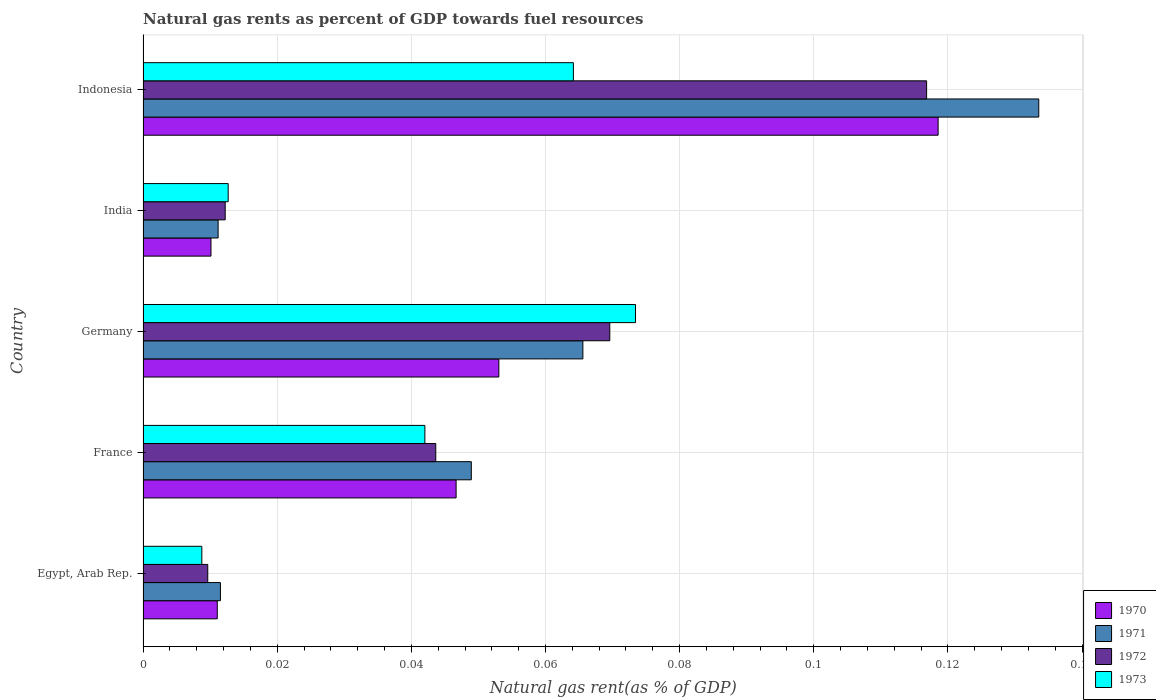How many groups of bars are there?
Your answer should be compact. 5. Are the number of bars per tick equal to the number of legend labels?
Make the answer very short. Yes. How many bars are there on the 4th tick from the top?
Ensure brevity in your answer.  4. How many bars are there on the 3rd tick from the bottom?
Make the answer very short. 4. What is the label of the 3rd group of bars from the top?
Make the answer very short. Germany. In how many cases, is the number of bars for a given country not equal to the number of legend labels?
Give a very brief answer. 0. What is the natural gas rent in 1972 in India?
Give a very brief answer. 0.01. Across all countries, what is the maximum natural gas rent in 1970?
Offer a terse response. 0.12. Across all countries, what is the minimum natural gas rent in 1973?
Ensure brevity in your answer.  0.01. In which country was the natural gas rent in 1972 minimum?
Ensure brevity in your answer.  Egypt, Arab Rep. What is the total natural gas rent in 1971 in the graph?
Give a very brief answer. 0.27. What is the difference between the natural gas rent in 1972 in France and that in India?
Keep it short and to the point. 0.03. What is the difference between the natural gas rent in 1972 in Egypt, Arab Rep. and the natural gas rent in 1971 in France?
Your answer should be compact. -0.04. What is the average natural gas rent in 1970 per country?
Provide a short and direct response. 0.05. What is the difference between the natural gas rent in 1972 and natural gas rent in 1971 in Germany?
Offer a very short reply. 0. In how many countries, is the natural gas rent in 1972 greater than 0.116 %?
Provide a succinct answer. 1. What is the ratio of the natural gas rent in 1970 in India to that in Indonesia?
Your answer should be compact. 0.09. Is the natural gas rent in 1971 in Egypt, Arab Rep. less than that in Indonesia?
Your answer should be compact. Yes. Is the difference between the natural gas rent in 1972 in Germany and Indonesia greater than the difference between the natural gas rent in 1971 in Germany and Indonesia?
Your response must be concise. Yes. What is the difference between the highest and the second highest natural gas rent in 1970?
Offer a very short reply. 0.07. What is the difference between the highest and the lowest natural gas rent in 1971?
Offer a very short reply. 0.12. In how many countries, is the natural gas rent in 1973 greater than the average natural gas rent in 1973 taken over all countries?
Offer a very short reply. 3. What does the 1st bar from the top in Indonesia represents?
Provide a short and direct response. 1973. Is it the case that in every country, the sum of the natural gas rent in 1972 and natural gas rent in 1970 is greater than the natural gas rent in 1971?
Provide a succinct answer. Yes. Are the values on the major ticks of X-axis written in scientific E-notation?
Your response must be concise. No. Does the graph contain grids?
Provide a succinct answer. Yes. Where does the legend appear in the graph?
Provide a succinct answer. Bottom right. What is the title of the graph?
Ensure brevity in your answer.  Natural gas rents as percent of GDP towards fuel resources. Does "1990" appear as one of the legend labels in the graph?
Give a very brief answer. No. What is the label or title of the X-axis?
Offer a very short reply. Natural gas rent(as % of GDP). What is the Natural gas rent(as % of GDP) of 1970 in Egypt, Arab Rep.?
Offer a very short reply. 0.01. What is the Natural gas rent(as % of GDP) in 1971 in Egypt, Arab Rep.?
Keep it short and to the point. 0.01. What is the Natural gas rent(as % of GDP) in 1972 in Egypt, Arab Rep.?
Keep it short and to the point. 0.01. What is the Natural gas rent(as % of GDP) of 1973 in Egypt, Arab Rep.?
Keep it short and to the point. 0.01. What is the Natural gas rent(as % of GDP) in 1970 in France?
Your response must be concise. 0.05. What is the Natural gas rent(as % of GDP) in 1971 in France?
Your answer should be very brief. 0.05. What is the Natural gas rent(as % of GDP) in 1972 in France?
Your answer should be very brief. 0.04. What is the Natural gas rent(as % of GDP) in 1973 in France?
Offer a terse response. 0.04. What is the Natural gas rent(as % of GDP) in 1970 in Germany?
Keep it short and to the point. 0.05. What is the Natural gas rent(as % of GDP) of 1971 in Germany?
Offer a very short reply. 0.07. What is the Natural gas rent(as % of GDP) in 1972 in Germany?
Your answer should be compact. 0.07. What is the Natural gas rent(as % of GDP) in 1973 in Germany?
Your answer should be very brief. 0.07. What is the Natural gas rent(as % of GDP) of 1970 in India?
Keep it short and to the point. 0.01. What is the Natural gas rent(as % of GDP) in 1971 in India?
Give a very brief answer. 0.01. What is the Natural gas rent(as % of GDP) in 1972 in India?
Your answer should be very brief. 0.01. What is the Natural gas rent(as % of GDP) in 1973 in India?
Your answer should be compact. 0.01. What is the Natural gas rent(as % of GDP) of 1970 in Indonesia?
Provide a succinct answer. 0.12. What is the Natural gas rent(as % of GDP) of 1971 in Indonesia?
Your answer should be very brief. 0.13. What is the Natural gas rent(as % of GDP) of 1972 in Indonesia?
Offer a terse response. 0.12. What is the Natural gas rent(as % of GDP) of 1973 in Indonesia?
Offer a very short reply. 0.06. Across all countries, what is the maximum Natural gas rent(as % of GDP) of 1970?
Provide a short and direct response. 0.12. Across all countries, what is the maximum Natural gas rent(as % of GDP) of 1971?
Keep it short and to the point. 0.13. Across all countries, what is the maximum Natural gas rent(as % of GDP) of 1972?
Give a very brief answer. 0.12. Across all countries, what is the maximum Natural gas rent(as % of GDP) in 1973?
Give a very brief answer. 0.07. Across all countries, what is the minimum Natural gas rent(as % of GDP) of 1970?
Provide a short and direct response. 0.01. Across all countries, what is the minimum Natural gas rent(as % of GDP) of 1971?
Ensure brevity in your answer.  0.01. Across all countries, what is the minimum Natural gas rent(as % of GDP) in 1972?
Your answer should be very brief. 0.01. Across all countries, what is the minimum Natural gas rent(as % of GDP) of 1973?
Make the answer very short. 0.01. What is the total Natural gas rent(as % of GDP) of 1970 in the graph?
Make the answer very short. 0.24. What is the total Natural gas rent(as % of GDP) in 1971 in the graph?
Your response must be concise. 0.27. What is the total Natural gas rent(as % of GDP) of 1972 in the graph?
Your answer should be compact. 0.25. What is the total Natural gas rent(as % of GDP) in 1973 in the graph?
Offer a terse response. 0.2. What is the difference between the Natural gas rent(as % of GDP) of 1970 in Egypt, Arab Rep. and that in France?
Your response must be concise. -0.04. What is the difference between the Natural gas rent(as % of GDP) in 1971 in Egypt, Arab Rep. and that in France?
Your answer should be very brief. -0.04. What is the difference between the Natural gas rent(as % of GDP) in 1972 in Egypt, Arab Rep. and that in France?
Provide a short and direct response. -0.03. What is the difference between the Natural gas rent(as % of GDP) in 1973 in Egypt, Arab Rep. and that in France?
Ensure brevity in your answer.  -0.03. What is the difference between the Natural gas rent(as % of GDP) of 1970 in Egypt, Arab Rep. and that in Germany?
Offer a very short reply. -0.04. What is the difference between the Natural gas rent(as % of GDP) in 1971 in Egypt, Arab Rep. and that in Germany?
Provide a succinct answer. -0.05. What is the difference between the Natural gas rent(as % of GDP) of 1972 in Egypt, Arab Rep. and that in Germany?
Offer a terse response. -0.06. What is the difference between the Natural gas rent(as % of GDP) of 1973 in Egypt, Arab Rep. and that in Germany?
Offer a terse response. -0.06. What is the difference between the Natural gas rent(as % of GDP) of 1970 in Egypt, Arab Rep. and that in India?
Provide a short and direct response. 0. What is the difference between the Natural gas rent(as % of GDP) of 1972 in Egypt, Arab Rep. and that in India?
Ensure brevity in your answer.  -0. What is the difference between the Natural gas rent(as % of GDP) of 1973 in Egypt, Arab Rep. and that in India?
Your answer should be very brief. -0. What is the difference between the Natural gas rent(as % of GDP) of 1970 in Egypt, Arab Rep. and that in Indonesia?
Keep it short and to the point. -0.11. What is the difference between the Natural gas rent(as % of GDP) of 1971 in Egypt, Arab Rep. and that in Indonesia?
Offer a very short reply. -0.12. What is the difference between the Natural gas rent(as % of GDP) of 1972 in Egypt, Arab Rep. and that in Indonesia?
Ensure brevity in your answer.  -0.11. What is the difference between the Natural gas rent(as % of GDP) of 1973 in Egypt, Arab Rep. and that in Indonesia?
Your response must be concise. -0.06. What is the difference between the Natural gas rent(as % of GDP) of 1970 in France and that in Germany?
Give a very brief answer. -0.01. What is the difference between the Natural gas rent(as % of GDP) in 1971 in France and that in Germany?
Your answer should be very brief. -0.02. What is the difference between the Natural gas rent(as % of GDP) in 1972 in France and that in Germany?
Make the answer very short. -0.03. What is the difference between the Natural gas rent(as % of GDP) of 1973 in France and that in Germany?
Keep it short and to the point. -0.03. What is the difference between the Natural gas rent(as % of GDP) of 1970 in France and that in India?
Offer a terse response. 0.04. What is the difference between the Natural gas rent(as % of GDP) of 1971 in France and that in India?
Provide a short and direct response. 0.04. What is the difference between the Natural gas rent(as % of GDP) of 1972 in France and that in India?
Your answer should be very brief. 0.03. What is the difference between the Natural gas rent(as % of GDP) in 1973 in France and that in India?
Keep it short and to the point. 0.03. What is the difference between the Natural gas rent(as % of GDP) of 1970 in France and that in Indonesia?
Your answer should be compact. -0.07. What is the difference between the Natural gas rent(as % of GDP) of 1971 in France and that in Indonesia?
Your answer should be compact. -0.08. What is the difference between the Natural gas rent(as % of GDP) of 1972 in France and that in Indonesia?
Your response must be concise. -0.07. What is the difference between the Natural gas rent(as % of GDP) of 1973 in France and that in Indonesia?
Keep it short and to the point. -0.02. What is the difference between the Natural gas rent(as % of GDP) in 1970 in Germany and that in India?
Give a very brief answer. 0.04. What is the difference between the Natural gas rent(as % of GDP) in 1971 in Germany and that in India?
Make the answer very short. 0.05. What is the difference between the Natural gas rent(as % of GDP) of 1972 in Germany and that in India?
Provide a short and direct response. 0.06. What is the difference between the Natural gas rent(as % of GDP) in 1973 in Germany and that in India?
Offer a terse response. 0.06. What is the difference between the Natural gas rent(as % of GDP) of 1970 in Germany and that in Indonesia?
Keep it short and to the point. -0.07. What is the difference between the Natural gas rent(as % of GDP) of 1971 in Germany and that in Indonesia?
Give a very brief answer. -0.07. What is the difference between the Natural gas rent(as % of GDP) in 1972 in Germany and that in Indonesia?
Give a very brief answer. -0.05. What is the difference between the Natural gas rent(as % of GDP) of 1973 in Germany and that in Indonesia?
Make the answer very short. 0.01. What is the difference between the Natural gas rent(as % of GDP) in 1970 in India and that in Indonesia?
Keep it short and to the point. -0.11. What is the difference between the Natural gas rent(as % of GDP) in 1971 in India and that in Indonesia?
Provide a short and direct response. -0.12. What is the difference between the Natural gas rent(as % of GDP) of 1972 in India and that in Indonesia?
Provide a short and direct response. -0.1. What is the difference between the Natural gas rent(as % of GDP) of 1973 in India and that in Indonesia?
Your answer should be compact. -0.05. What is the difference between the Natural gas rent(as % of GDP) of 1970 in Egypt, Arab Rep. and the Natural gas rent(as % of GDP) of 1971 in France?
Offer a terse response. -0.04. What is the difference between the Natural gas rent(as % of GDP) of 1970 in Egypt, Arab Rep. and the Natural gas rent(as % of GDP) of 1972 in France?
Your answer should be compact. -0.03. What is the difference between the Natural gas rent(as % of GDP) of 1970 in Egypt, Arab Rep. and the Natural gas rent(as % of GDP) of 1973 in France?
Give a very brief answer. -0.03. What is the difference between the Natural gas rent(as % of GDP) of 1971 in Egypt, Arab Rep. and the Natural gas rent(as % of GDP) of 1972 in France?
Your response must be concise. -0.03. What is the difference between the Natural gas rent(as % of GDP) in 1971 in Egypt, Arab Rep. and the Natural gas rent(as % of GDP) in 1973 in France?
Give a very brief answer. -0.03. What is the difference between the Natural gas rent(as % of GDP) in 1972 in Egypt, Arab Rep. and the Natural gas rent(as % of GDP) in 1973 in France?
Give a very brief answer. -0.03. What is the difference between the Natural gas rent(as % of GDP) in 1970 in Egypt, Arab Rep. and the Natural gas rent(as % of GDP) in 1971 in Germany?
Ensure brevity in your answer.  -0.05. What is the difference between the Natural gas rent(as % of GDP) in 1970 in Egypt, Arab Rep. and the Natural gas rent(as % of GDP) in 1972 in Germany?
Your answer should be compact. -0.06. What is the difference between the Natural gas rent(as % of GDP) of 1970 in Egypt, Arab Rep. and the Natural gas rent(as % of GDP) of 1973 in Germany?
Your response must be concise. -0.06. What is the difference between the Natural gas rent(as % of GDP) of 1971 in Egypt, Arab Rep. and the Natural gas rent(as % of GDP) of 1972 in Germany?
Ensure brevity in your answer.  -0.06. What is the difference between the Natural gas rent(as % of GDP) in 1971 in Egypt, Arab Rep. and the Natural gas rent(as % of GDP) in 1973 in Germany?
Make the answer very short. -0.06. What is the difference between the Natural gas rent(as % of GDP) of 1972 in Egypt, Arab Rep. and the Natural gas rent(as % of GDP) of 1973 in Germany?
Your answer should be compact. -0.06. What is the difference between the Natural gas rent(as % of GDP) of 1970 in Egypt, Arab Rep. and the Natural gas rent(as % of GDP) of 1971 in India?
Your answer should be compact. -0. What is the difference between the Natural gas rent(as % of GDP) of 1970 in Egypt, Arab Rep. and the Natural gas rent(as % of GDP) of 1972 in India?
Keep it short and to the point. -0. What is the difference between the Natural gas rent(as % of GDP) of 1970 in Egypt, Arab Rep. and the Natural gas rent(as % of GDP) of 1973 in India?
Offer a terse response. -0. What is the difference between the Natural gas rent(as % of GDP) of 1971 in Egypt, Arab Rep. and the Natural gas rent(as % of GDP) of 1972 in India?
Your response must be concise. -0. What is the difference between the Natural gas rent(as % of GDP) of 1971 in Egypt, Arab Rep. and the Natural gas rent(as % of GDP) of 1973 in India?
Make the answer very short. -0. What is the difference between the Natural gas rent(as % of GDP) in 1972 in Egypt, Arab Rep. and the Natural gas rent(as % of GDP) in 1973 in India?
Your answer should be very brief. -0. What is the difference between the Natural gas rent(as % of GDP) of 1970 in Egypt, Arab Rep. and the Natural gas rent(as % of GDP) of 1971 in Indonesia?
Provide a succinct answer. -0.12. What is the difference between the Natural gas rent(as % of GDP) in 1970 in Egypt, Arab Rep. and the Natural gas rent(as % of GDP) in 1972 in Indonesia?
Ensure brevity in your answer.  -0.11. What is the difference between the Natural gas rent(as % of GDP) of 1970 in Egypt, Arab Rep. and the Natural gas rent(as % of GDP) of 1973 in Indonesia?
Give a very brief answer. -0.05. What is the difference between the Natural gas rent(as % of GDP) of 1971 in Egypt, Arab Rep. and the Natural gas rent(as % of GDP) of 1972 in Indonesia?
Offer a terse response. -0.11. What is the difference between the Natural gas rent(as % of GDP) of 1971 in Egypt, Arab Rep. and the Natural gas rent(as % of GDP) of 1973 in Indonesia?
Your answer should be compact. -0.05. What is the difference between the Natural gas rent(as % of GDP) in 1972 in Egypt, Arab Rep. and the Natural gas rent(as % of GDP) in 1973 in Indonesia?
Give a very brief answer. -0.05. What is the difference between the Natural gas rent(as % of GDP) in 1970 in France and the Natural gas rent(as % of GDP) in 1971 in Germany?
Provide a short and direct response. -0.02. What is the difference between the Natural gas rent(as % of GDP) of 1970 in France and the Natural gas rent(as % of GDP) of 1972 in Germany?
Keep it short and to the point. -0.02. What is the difference between the Natural gas rent(as % of GDP) in 1970 in France and the Natural gas rent(as % of GDP) in 1973 in Germany?
Provide a succinct answer. -0.03. What is the difference between the Natural gas rent(as % of GDP) of 1971 in France and the Natural gas rent(as % of GDP) of 1972 in Germany?
Provide a short and direct response. -0.02. What is the difference between the Natural gas rent(as % of GDP) in 1971 in France and the Natural gas rent(as % of GDP) in 1973 in Germany?
Ensure brevity in your answer.  -0.02. What is the difference between the Natural gas rent(as % of GDP) in 1972 in France and the Natural gas rent(as % of GDP) in 1973 in Germany?
Your response must be concise. -0.03. What is the difference between the Natural gas rent(as % of GDP) of 1970 in France and the Natural gas rent(as % of GDP) of 1971 in India?
Offer a terse response. 0.04. What is the difference between the Natural gas rent(as % of GDP) in 1970 in France and the Natural gas rent(as % of GDP) in 1972 in India?
Provide a short and direct response. 0.03. What is the difference between the Natural gas rent(as % of GDP) in 1970 in France and the Natural gas rent(as % of GDP) in 1973 in India?
Keep it short and to the point. 0.03. What is the difference between the Natural gas rent(as % of GDP) in 1971 in France and the Natural gas rent(as % of GDP) in 1972 in India?
Make the answer very short. 0.04. What is the difference between the Natural gas rent(as % of GDP) of 1971 in France and the Natural gas rent(as % of GDP) of 1973 in India?
Your answer should be very brief. 0.04. What is the difference between the Natural gas rent(as % of GDP) in 1972 in France and the Natural gas rent(as % of GDP) in 1973 in India?
Ensure brevity in your answer.  0.03. What is the difference between the Natural gas rent(as % of GDP) of 1970 in France and the Natural gas rent(as % of GDP) of 1971 in Indonesia?
Your answer should be very brief. -0.09. What is the difference between the Natural gas rent(as % of GDP) in 1970 in France and the Natural gas rent(as % of GDP) in 1972 in Indonesia?
Your answer should be compact. -0.07. What is the difference between the Natural gas rent(as % of GDP) in 1970 in France and the Natural gas rent(as % of GDP) in 1973 in Indonesia?
Offer a very short reply. -0.02. What is the difference between the Natural gas rent(as % of GDP) in 1971 in France and the Natural gas rent(as % of GDP) in 1972 in Indonesia?
Make the answer very short. -0.07. What is the difference between the Natural gas rent(as % of GDP) of 1971 in France and the Natural gas rent(as % of GDP) of 1973 in Indonesia?
Your answer should be very brief. -0.02. What is the difference between the Natural gas rent(as % of GDP) in 1972 in France and the Natural gas rent(as % of GDP) in 1973 in Indonesia?
Give a very brief answer. -0.02. What is the difference between the Natural gas rent(as % of GDP) of 1970 in Germany and the Natural gas rent(as % of GDP) of 1971 in India?
Offer a terse response. 0.04. What is the difference between the Natural gas rent(as % of GDP) in 1970 in Germany and the Natural gas rent(as % of GDP) in 1972 in India?
Provide a succinct answer. 0.04. What is the difference between the Natural gas rent(as % of GDP) in 1970 in Germany and the Natural gas rent(as % of GDP) in 1973 in India?
Make the answer very short. 0.04. What is the difference between the Natural gas rent(as % of GDP) of 1971 in Germany and the Natural gas rent(as % of GDP) of 1972 in India?
Your answer should be compact. 0.05. What is the difference between the Natural gas rent(as % of GDP) in 1971 in Germany and the Natural gas rent(as % of GDP) in 1973 in India?
Provide a short and direct response. 0.05. What is the difference between the Natural gas rent(as % of GDP) of 1972 in Germany and the Natural gas rent(as % of GDP) of 1973 in India?
Keep it short and to the point. 0.06. What is the difference between the Natural gas rent(as % of GDP) in 1970 in Germany and the Natural gas rent(as % of GDP) in 1971 in Indonesia?
Make the answer very short. -0.08. What is the difference between the Natural gas rent(as % of GDP) of 1970 in Germany and the Natural gas rent(as % of GDP) of 1972 in Indonesia?
Your answer should be compact. -0.06. What is the difference between the Natural gas rent(as % of GDP) in 1970 in Germany and the Natural gas rent(as % of GDP) in 1973 in Indonesia?
Offer a terse response. -0.01. What is the difference between the Natural gas rent(as % of GDP) in 1971 in Germany and the Natural gas rent(as % of GDP) in 1972 in Indonesia?
Make the answer very short. -0.05. What is the difference between the Natural gas rent(as % of GDP) of 1971 in Germany and the Natural gas rent(as % of GDP) of 1973 in Indonesia?
Your answer should be compact. 0. What is the difference between the Natural gas rent(as % of GDP) in 1972 in Germany and the Natural gas rent(as % of GDP) in 1973 in Indonesia?
Your answer should be very brief. 0.01. What is the difference between the Natural gas rent(as % of GDP) in 1970 in India and the Natural gas rent(as % of GDP) in 1971 in Indonesia?
Provide a succinct answer. -0.12. What is the difference between the Natural gas rent(as % of GDP) in 1970 in India and the Natural gas rent(as % of GDP) in 1972 in Indonesia?
Your answer should be very brief. -0.11. What is the difference between the Natural gas rent(as % of GDP) of 1970 in India and the Natural gas rent(as % of GDP) of 1973 in Indonesia?
Keep it short and to the point. -0.05. What is the difference between the Natural gas rent(as % of GDP) in 1971 in India and the Natural gas rent(as % of GDP) in 1972 in Indonesia?
Provide a short and direct response. -0.11. What is the difference between the Natural gas rent(as % of GDP) of 1971 in India and the Natural gas rent(as % of GDP) of 1973 in Indonesia?
Provide a short and direct response. -0.05. What is the difference between the Natural gas rent(as % of GDP) of 1972 in India and the Natural gas rent(as % of GDP) of 1973 in Indonesia?
Keep it short and to the point. -0.05. What is the average Natural gas rent(as % of GDP) of 1970 per country?
Your answer should be compact. 0.05. What is the average Natural gas rent(as % of GDP) in 1971 per country?
Keep it short and to the point. 0.05. What is the average Natural gas rent(as % of GDP) in 1972 per country?
Make the answer very short. 0.05. What is the average Natural gas rent(as % of GDP) in 1973 per country?
Your answer should be compact. 0.04. What is the difference between the Natural gas rent(as % of GDP) in 1970 and Natural gas rent(as % of GDP) in 1971 in Egypt, Arab Rep.?
Provide a succinct answer. -0. What is the difference between the Natural gas rent(as % of GDP) in 1970 and Natural gas rent(as % of GDP) in 1972 in Egypt, Arab Rep.?
Offer a terse response. 0. What is the difference between the Natural gas rent(as % of GDP) of 1970 and Natural gas rent(as % of GDP) of 1973 in Egypt, Arab Rep.?
Make the answer very short. 0. What is the difference between the Natural gas rent(as % of GDP) in 1971 and Natural gas rent(as % of GDP) in 1972 in Egypt, Arab Rep.?
Provide a short and direct response. 0. What is the difference between the Natural gas rent(as % of GDP) in 1971 and Natural gas rent(as % of GDP) in 1973 in Egypt, Arab Rep.?
Offer a terse response. 0. What is the difference between the Natural gas rent(as % of GDP) of 1972 and Natural gas rent(as % of GDP) of 1973 in Egypt, Arab Rep.?
Make the answer very short. 0. What is the difference between the Natural gas rent(as % of GDP) of 1970 and Natural gas rent(as % of GDP) of 1971 in France?
Provide a short and direct response. -0. What is the difference between the Natural gas rent(as % of GDP) in 1970 and Natural gas rent(as % of GDP) in 1972 in France?
Keep it short and to the point. 0. What is the difference between the Natural gas rent(as % of GDP) in 1970 and Natural gas rent(as % of GDP) in 1973 in France?
Offer a very short reply. 0. What is the difference between the Natural gas rent(as % of GDP) in 1971 and Natural gas rent(as % of GDP) in 1972 in France?
Your answer should be compact. 0.01. What is the difference between the Natural gas rent(as % of GDP) of 1971 and Natural gas rent(as % of GDP) of 1973 in France?
Your response must be concise. 0.01. What is the difference between the Natural gas rent(as % of GDP) in 1972 and Natural gas rent(as % of GDP) in 1973 in France?
Keep it short and to the point. 0. What is the difference between the Natural gas rent(as % of GDP) in 1970 and Natural gas rent(as % of GDP) in 1971 in Germany?
Make the answer very short. -0.01. What is the difference between the Natural gas rent(as % of GDP) of 1970 and Natural gas rent(as % of GDP) of 1972 in Germany?
Make the answer very short. -0.02. What is the difference between the Natural gas rent(as % of GDP) in 1970 and Natural gas rent(as % of GDP) in 1973 in Germany?
Make the answer very short. -0.02. What is the difference between the Natural gas rent(as % of GDP) in 1971 and Natural gas rent(as % of GDP) in 1972 in Germany?
Give a very brief answer. -0. What is the difference between the Natural gas rent(as % of GDP) in 1971 and Natural gas rent(as % of GDP) in 1973 in Germany?
Ensure brevity in your answer.  -0.01. What is the difference between the Natural gas rent(as % of GDP) of 1972 and Natural gas rent(as % of GDP) of 1973 in Germany?
Ensure brevity in your answer.  -0. What is the difference between the Natural gas rent(as % of GDP) of 1970 and Natural gas rent(as % of GDP) of 1971 in India?
Offer a terse response. -0. What is the difference between the Natural gas rent(as % of GDP) in 1970 and Natural gas rent(as % of GDP) in 1972 in India?
Make the answer very short. -0. What is the difference between the Natural gas rent(as % of GDP) in 1970 and Natural gas rent(as % of GDP) in 1973 in India?
Offer a very short reply. -0. What is the difference between the Natural gas rent(as % of GDP) in 1971 and Natural gas rent(as % of GDP) in 1972 in India?
Your answer should be compact. -0. What is the difference between the Natural gas rent(as % of GDP) in 1971 and Natural gas rent(as % of GDP) in 1973 in India?
Your answer should be very brief. -0. What is the difference between the Natural gas rent(as % of GDP) in 1972 and Natural gas rent(as % of GDP) in 1973 in India?
Your response must be concise. -0. What is the difference between the Natural gas rent(as % of GDP) in 1970 and Natural gas rent(as % of GDP) in 1971 in Indonesia?
Ensure brevity in your answer.  -0.01. What is the difference between the Natural gas rent(as % of GDP) of 1970 and Natural gas rent(as % of GDP) of 1972 in Indonesia?
Provide a succinct answer. 0. What is the difference between the Natural gas rent(as % of GDP) of 1970 and Natural gas rent(as % of GDP) of 1973 in Indonesia?
Offer a very short reply. 0.05. What is the difference between the Natural gas rent(as % of GDP) in 1971 and Natural gas rent(as % of GDP) in 1972 in Indonesia?
Your response must be concise. 0.02. What is the difference between the Natural gas rent(as % of GDP) in 1971 and Natural gas rent(as % of GDP) in 1973 in Indonesia?
Keep it short and to the point. 0.07. What is the difference between the Natural gas rent(as % of GDP) in 1972 and Natural gas rent(as % of GDP) in 1973 in Indonesia?
Your response must be concise. 0.05. What is the ratio of the Natural gas rent(as % of GDP) in 1970 in Egypt, Arab Rep. to that in France?
Your answer should be very brief. 0.24. What is the ratio of the Natural gas rent(as % of GDP) in 1971 in Egypt, Arab Rep. to that in France?
Make the answer very short. 0.24. What is the ratio of the Natural gas rent(as % of GDP) in 1972 in Egypt, Arab Rep. to that in France?
Your answer should be very brief. 0.22. What is the ratio of the Natural gas rent(as % of GDP) in 1973 in Egypt, Arab Rep. to that in France?
Give a very brief answer. 0.21. What is the ratio of the Natural gas rent(as % of GDP) of 1970 in Egypt, Arab Rep. to that in Germany?
Offer a terse response. 0.21. What is the ratio of the Natural gas rent(as % of GDP) of 1971 in Egypt, Arab Rep. to that in Germany?
Your answer should be very brief. 0.18. What is the ratio of the Natural gas rent(as % of GDP) in 1972 in Egypt, Arab Rep. to that in Germany?
Give a very brief answer. 0.14. What is the ratio of the Natural gas rent(as % of GDP) in 1973 in Egypt, Arab Rep. to that in Germany?
Your response must be concise. 0.12. What is the ratio of the Natural gas rent(as % of GDP) in 1970 in Egypt, Arab Rep. to that in India?
Ensure brevity in your answer.  1.09. What is the ratio of the Natural gas rent(as % of GDP) in 1971 in Egypt, Arab Rep. to that in India?
Offer a terse response. 1.03. What is the ratio of the Natural gas rent(as % of GDP) of 1972 in Egypt, Arab Rep. to that in India?
Keep it short and to the point. 0.79. What is the ratio of the Natural gas rent(as % of GDP) of 1973 in Egypt, Arab Rep. to that in India?
Keep it short and to the point. 0.69. What is the ratio of the Natural gas rent(as % of GDP) in 1970 in Egypt, Arab Rep. to that in Indonesia?
Your response must be concise. 0.09. What is the ratio of the Natural gas rent(as % of GDP) of 1971 in Egypt, Arab Rep. to that in Indonesia?
Provide a short and direct response. 0.09. What is the ratio of the Natural gas rent(as % of GDP) of 1972 in Egypt, Arab Rep. to that in Indonesia?
Provide a short and direct response. 0.08. What is the ratio of the Natural gas rent(as % of GDP) of 1973 in Egypt, Arab Rep. to that in Indonesia?
Give a very brief answer. 0.14. What is the ratio of the Natural gas rent(as % of GDP) in 1970 in France to that in Germany?
Make the answer very short. 0.88. What is the ratio of the Natural gas rent(as % of GDP) in 1971 in France to that in Germany?
Your response must be concise. 0.75. What is the ratio of the Natural gas rent(as % of GDP) in 1972 in France to that in Germany?
Provide a succinct answer. 0.63. What is the ratio of the Natural gas rent(as % of GDP) in 1973 in France to that in Germany?
Offer a very short reply. 0.57. What is the ratio of the Natural gas rent(as % of GDP) of 1970 in France to that in India?
Ensure brevity in your answer.  4.61. What is the ratio of the Natural gas rent(as % of GDP) of 1971 in France to that in India?
Keep it short and to the point. 4.37. What is the ratio of the Natural gas rent(as % of GDP) of 1972 in France to that in India?
Your answer should be compact. 3.56. What is the ratio of the Natural gas rent(as % of GDP) in 1973 in France to that in India?
Make the answer very short. 3.31. What is the ratio of the Natural gas rent(as % of GDP) in 1970 in France to that in Indonesia?
Keep it short and to the point. 0.39. What is the ratio of the Natural gas rent(as % of GDP) in 1971 in France to that in Indonesia?
Your answer should be very brief. 0.37. What is the ratio of the Natural gas rent(as % of GDP) of 1972 in France to that in Indonesia?
Your response must be concise. 0.37. What is the ratio of the Natural gas rent(as % of GDP) in 1973 in France to that in Indonesia?
Your response must be concise. 0.65. What is the ratio of the Natural gas rent(as % of GDP) in 1970 in Germany to that in India?
Your answer should be compact. 5.24. What is the ratio of the Natural gas rent(as % of GDP) in 1971 in Germany to that in India?
Your answer should be very brief. 5.86. What is the ratio of the Natural gas rent(as % of GDP) in 1972 in Germany to that in India?
Ensure brevity in your answer.  5.68. What is the ratio of the Natural gas rent(as % of GDP) of 1973 in Germany to that in India?
Provide a succinct answer. 5.79. What is the ratio of the Natural gas rent(as % of GDP) of 1970 in Germany to that in Indonesia?
Provide a succinct answer. 0.45. What is the ratio of the Natural gas rent(as % of GDP) of 1971 in Germany to that in Indonesia?
Your answer should be compact. 0.49. What is the ratio of the Natural gas rent(as % of GDP) in 1972 in Germany to that in Indonesia?
Your response must be concise. 0.6. What is the ratio of the Natural gas rent(as % of GDP) in 1973 in Germany to that in Indonesia?
Your response must be concise. 1.14. What is the ratio of the Natural gas rent(as % of GDP) in 1970 in India to that in Indonesia?
Provide a short and direct response. 0.09. What is the ratio of the Natural gas rent(as % of GDP) of 1971 in India to that in Indonesia?
Ensure brevity in your answer.  0.08. What is the ratio of the Natural gas rent(as % of GDP) in 1972 in India to that in Indonesia?
Your answer should be compact. 0.1. What is the ratio of the Natural gas rent(as % of GDP) of 1973 in India to that in Indonesia?
Your answer should be very brief. 0.2. What is the difference between the highest and the second highest Natural gas rent(as % of GDP) of 1970?
Offer a terse response. 0.07. What is the difference between the highest and the second highest Natural gas rent(as % of GDP) in 1971?
Give a very brief answer. 0.07. What is the difference between the highest and the second highest Natural gas rent(as % of GDP) of 1972?
Offer a very short reply. 0.05. What is the difference between the highest and the second highest Natural gas rent(as % of GDP) of 1973?
Ensure brevity in your answer.  0.01. What is the difference between the highest and the lowest Natural gas rent(as % of GDP) of 1970?
Provide a succinct answer. 0.11. What is the difference between the highest and the lowest Natural gas rent(as % of GDP) in 1971?
Your answer should be very brief. 0.12. What is the difference between the highest and the lowest Natural gas rent(as % of GDP) of 1972?
Offer a terse response. 0.11. What is the difference between the highest and the lowest Natural gas rent(as % of GDP) in 1973?
Ensure brevity in your answer.  0.06. 